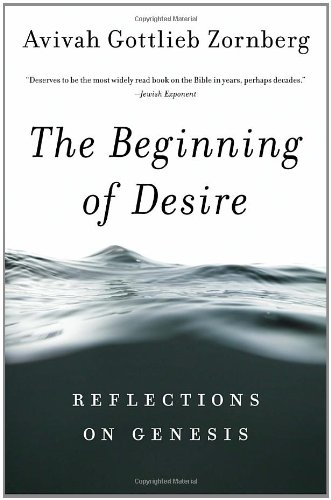Is this book related to Humor & Entertainment? No, this book does not fall into the Humor & Entertainment category; it is a serious scholarly text that ponders religious and existential themes found in the Bible. 